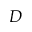Convert formula to latex. <formula><loc_0><loc_0><loc_500><loc_500>D</formula> 